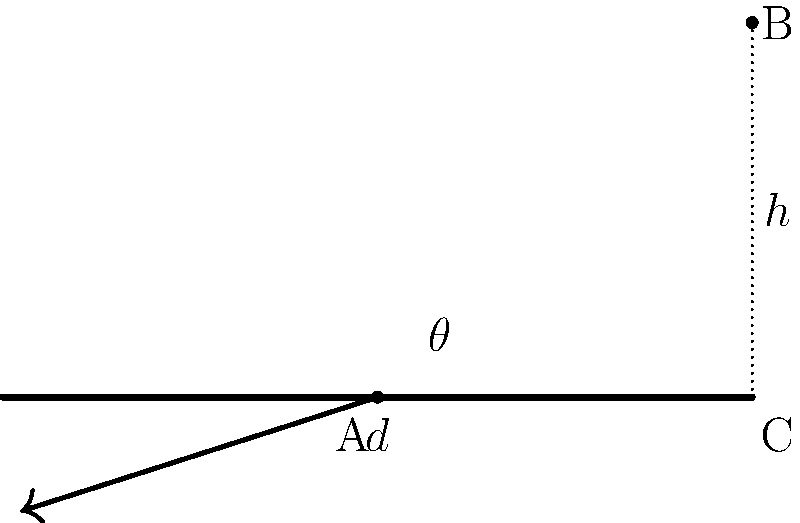In laparoscopic surgery, the optimal angle for instrument insertion is crucial for minimizing tissue damage and maximizing maneuverability. Consider a scenario where the distance from the insertion point (A) to the target organ (B) is 6 cm, and the abdominal wall thickness (h) is 3 cm. What is the optimal angle $\theta$ (in degrees) for instrument insertion to minimize the length of the instrument path through the abdominal wall? Use calculus to solve this optimization problem. Let's approach this step-by-step:

1) First, we need to express the length of the instrument path through the abdominal wall (d) in terms of $\theta$:

   $d = \frac{h}{\sin \theta}$

2) We want to minimize d. In calculus, to find the minimum of a function, we take its derivative and set it equal to zero:

   $\frac{d}{d\theta}(\frac{h}{\sin \theta}) = 0$

3) Using the chain rule:

   $-h \cdot \frac{\cos \theta}{\sin^2 \theta} = 0$

4) This equation is satisfied when $\cos \theta = 0$, which occurs when $\theta = 90°$.

5) To confirm this is a minimum, we can check the second derivative:

   $\frac{d^2}{d\theta^2}(\frac{h}{\sin \theta}) = h \cdot \frac{2\cos^2 \theta - \sin^2 \theta}{\sin^3 \theta}$

   At $\theta = 90°$, this is positive, confirming a minimum.

6) However, we need to consider the physical constraints. The hypotenuse of the triangle ABC must be 6 cm:

   $\sqrt{d^2 + h^2} = 6$

7) Substituting our expression for d:

   $\sqrt{(\frac{h}{\sin \theta})^2 + h^2} = 6$

8) Solving this equation:

   $\frac{h^2}{\sin^2 \theta} + h^2 = 36$
   $\frac{h^2}{\sin^2 \theta} = 36 - h^2 = 27$ (since $h = 3$)
   $\sin^2 \theta = \frac{h^2}{27} = \frac{1}{3}$
   $\sin \theta = \frac{1}{\sqrt{3}}$

9) Therefore, the optimal angle is:

   $\theta = \arcsin(\frac{1}{\sqrt{3}}) \approx 35.26°$
Answer: $35.26°$ 